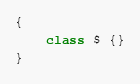<code> <loc_0><loc_0><loc_500><loc_500><_TypeScript_>
{
	class $ {}
}
</code> 